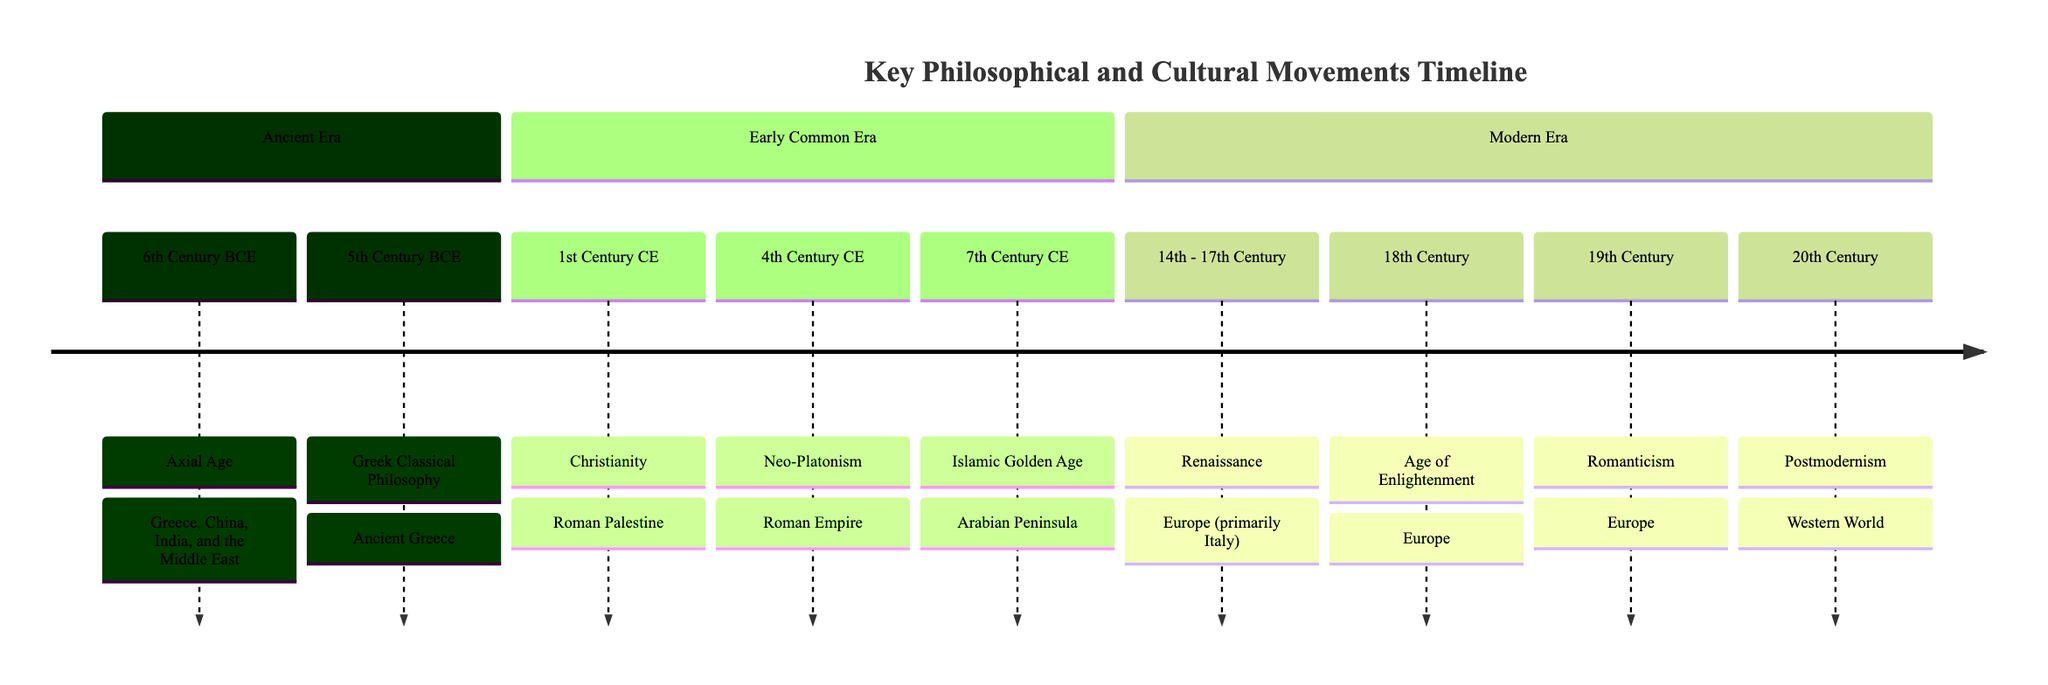What movement originated in Ancient Greece? The diagram indicates the "Greek Classical Philosophy" as the movement that originated in Ancient Greece during the 5th Century BCE.
Answer: Greek Classical Philosophy In which century did Christianity emerge? According to the timeline, Christianity emerged in the 1st Century CE.
Answer: 1st Century CE What is the defining characteristic of the Axial Age? The Axial Age is defined by the emergence of influential thinkers like Socrates, Confucius, Buddha, and Zoroaster, as shown in the description associated with that period.
Answer: Influential thinkers How many movements originated in Europe? By counting all the movements listed in the timeline that specify Europe as their origin, there are four: Renaissance, Age of Enlightenment, Romanticism, and Postmodernism.
Answer: Four What philosophical movement evolved from Plotinus' work? The timeline specifies that Neo-Platonism is the philosophical system developed by Plotinus, seeking to synthesize Plato's philosophy with spiritual elements.
Answer: Neo-Platonism Which movement spanned the 14th to 17th Century? The Renaissance movement is noted on the timeline to span the 14th to 17th Century.
Answer: Renaissance Which period features the Islamic Golden Age? The timeline indicates that the Islamic Golden Age occurred in the 7th Century CE.
Answer: 7th Century CE What is a key theme of the Age of Enlightenment? The description of the Age of Enlightenment emphasizes reason, individualism, and skepticism of traditional authorities as key themes of this intellectual movement.
Answer: Reason and individualism Which movement emphasizes emotion and nature as a reaction against rationalism? The timeline states that Romanticism is the movement that values emotion and nature, reacting against the rationalism of the Enlightenment.
Answer: Romanticism What connects the Axial Age to future philosophical traditions? The description notes that the Axial Age laid the foundations for distinct philosophical and religious traditions, establishing a significant influence that connects it to later movements.
Answer: Laid foundations 